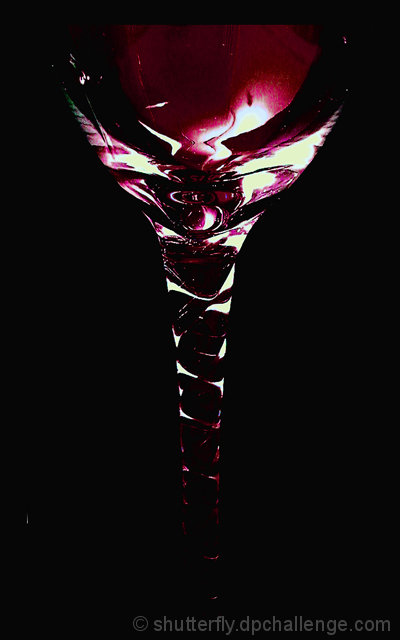Is the lighting sufficient? The lighting in the image creates a dramatic and moody atmosphere, highlighting the contours of the glass and the liquid it contains. While not conventionally bright, it serves to emphasize the subject artistically. 